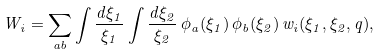<formula> <loc_0><loc_0><loc_500><loc_500>W _ { i } = \sum _ { a b } \int \frac { d \xi _ { 1 } } { \xi _ { 1 } } \int \frac { d \xi _ { 2 } } { \xi _ { 2 } } \, \phi _ { a } ( \xi _ { 1 } ) \, \phi _ { b } ( \xi _ { 2 } ) \, w _ { i } ( \xi _ { 1 } , \xi _ { 2 } , q ) ,</formula> 